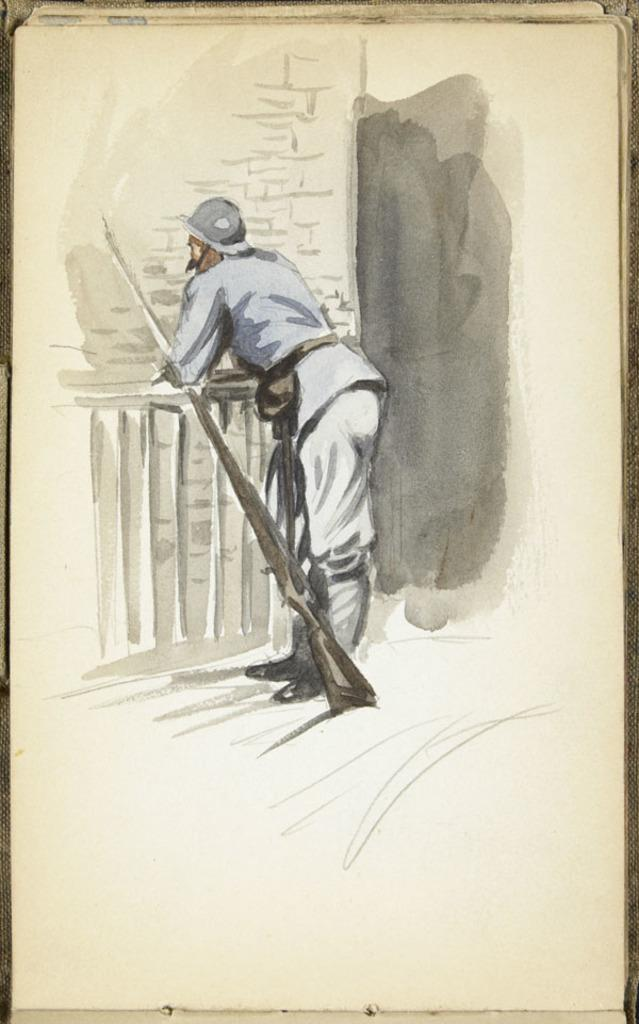What is the main subject of the image? There is a painting in the image. What is depicted in the painting? The painting depicts a person. What is the person doing in the painting? The person is resting their hands on a fencing. What object is beside the person in the painting? There is a gun beside the person in the painting. What is the person wearing in the painting? The person in the painting is wearing clothes and shoes. What type of bone can be seen in the painting? There is no bone present in the painting; it depicts a person resting their hands on a fencing and holding a gun. 